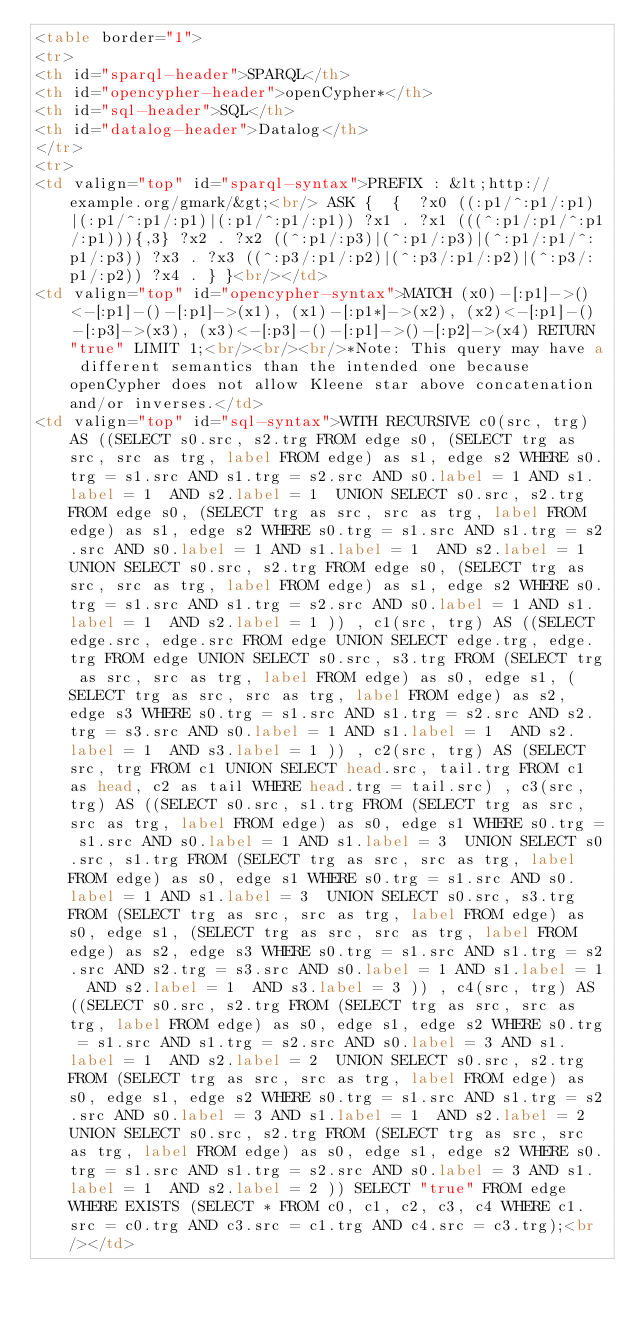Convert code to text. <code><loc_0><loc_0><loc_500><loc_500><_HTML_><table border="1">
<tr>
<th id="sparql-header">SPARQL</th>
<th id="opencypher-header">openCypher*</th>
<th id="sql-header">SQL</th>
<th id="datalog-header">Datalog</th>
</tr>
<tr>
<td valign="top" id="sparql-syntax">PREFIX : &lt;http://example.org/gmark/&gt;<br/> ASK {  {  ?x0 ((:p1/^:p1/:p1)|(:p1/^:p1/:p1)|(:p1/^:p1/:p1)) ?x1 . ?x1 (((^:p1/:p1/^:p1/:p1))){,3} ?x2 . ?x2 ((^:p1/:p3)|(^:p1/:p3)|(^:p1/:p1/^:p1/:p3)) ?x3 . ?x3 ((^:p3/:p1/:p2)|(^:p3/:p1/:p2)|(^:p3/:p1/:p2)) ?x4 . } }<br/></td>
<td valign="top" id="opencypher-syntax">MATCH (x0)-[:p1]->()<-[:p1]-()-[:p1]->(x1), (x1)-[:p1*]->(x2), (x2)<-[:p1]-()-[:p3]->(x3), (x3)<-[:p3]-()-[:p1]->()-[:p2]->(x4) RETURN "true" LIMIT 1;<br/><br/><br/>*Note: This query may have a different semantics than the intended one because openCypher does not allow Kleene star above concatenation and/or inverses.</td>
<td valign="top" id="sql-syntax">WITH RECURSIVE c0(src, trg) AS ((SELECT s0.src, s2.trg FROM edge s0, (SELECT trg as src, src as trg, label FROM edge) as s1, edge s2 WHERE s0.trg = s1.src AND s1.trg = s2.src AND s0.label = 1 AND s1.label = 1  AND s2.label = 1  UNION SELECT s0.src, s2.trg FROM edge s0, (SELECT trg as src, src as trg, label FROM edge) as s1, edge s2 WHERE s0.trg = s1.src AND s1.trg = s2.src AND s0.label = 1 AND s1.label = 1  AND s2.label = 1  UNION SELECT s0.src, s2.trg FROM edge s0, (SELECT trg as src, src as trg, label FROM edge) as s1, edge s2 WHERE s0.trg = s1.src AND s1.trg = s2.src AND s0.label = 1 AND s1.label = 1  AND s2.label = 1 )) , c1(src, trg) AS ((SELECT edge.src, edge.src FROM edge UNION SELECT edge.trg, edge.trg FROM edge UNION SELECT s0.src, s3.trg FROM (SELECT trg as src, src as trg, label FROM edge) as s0, edge s1, (SELECT trg as src, src as trg, label FROM edge) as s2, edge s3 WHERE s0.trg = s1.src AND s1.trg = s2.src AND s2.trg = s3.src AND s0.label = 1 AND s1.label = 1  AND s2.label = 1  AND s3.label = 1 )) , c2(src, trg) AS (SELECT src, trg FROM c1 UNION SELECT head.src, tail.trg FROM c1 as head, c2 as tail WHERE head.trg = tail.src) , c3(src, trg) AS ((SELECT s0.src, s1.trg FROM (SELECT trg as src, src as trg, label FROM edge) as s0, edge s1 WHERE s0.trg = s1.src AND s0.label = 1 AND s1.label = 3  UNION SELECT s0.src, s1.trg FROM (SELECT trg as src, src as trg, label FROM edge) as s0, edge s1 WHERE s0.trg = s1.src AND s0.label = 1 AND s1.label = 3  UNION SELECT s0.src, s3.trg FROM (SELECT trg as src, src as trg, label FROM edge) as s0, edge s1, (SELECT trg as src, src as trg, label FROM edge) as s2, edge s3 WHERE s0.trg = s1.src AND s1.trg = s2.src AND s2.trg = s3.src AND s0.label = 1 AND s1.label = 1  AND s2.label = 1  AND s3.label = 3 )) , c4(src, trg) AS ((SELECT s0.src, s2.trg FROM (SELECT trg as src, src as trg, label FROM edge) as s0, edge s1, edge s2 WHERE s0.trg = s1.src AND s1.trg = s2.src AND s0.label = 3 AND s1.label = 1  AND s2.label = 2  UNION SELECT s0.src, s2.trg FROM (SELECT trg as src, src as trg, label FROM edge) as s0, edge s1, edge s2 WHERE s0.trg = s1.src AND s1.trg = s2.src AND s0.label = 3 AND s1.label = 1  AND s2.label = 2  UNION SELECT s0.src, s2.trg FROM (SELECT trg as src, src as trg, label FROM edge) as s0, edge s1, edge s2 WHERE s0.trg = s1.src AND s1.trg = s2.src AND s0.label = 3 AND s1.label = 1  AND s2.label = 2 )) SELECT "true" FROM edge WHERE EXISTS (SELECT * FROM c0, c1, c2, c3, c4 WHERE c1.src = c0.trg AND c3.src = c1.trg AND c4.src = c3.trg);<br/></td></code> 